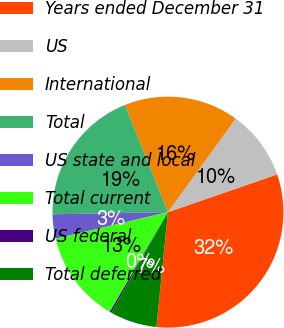Convert chart to OTSL. <chart><loc_0><loc_0><loc_500><loc_500><pie_chart><fcel>Years ended December 31<fcel>US<fcel>International<fcel>Total<fcel>US state and local<fcel>Total current<fcel>US federal<fcel>Total deferred<nl><fcel>31.88%<fcel>9.73%<fcel>16.06%<fcel>19.22%<fcel>3.4%<fcel>12.9%<fcel>0.24%<fcel>6.57%<nl></chart> 